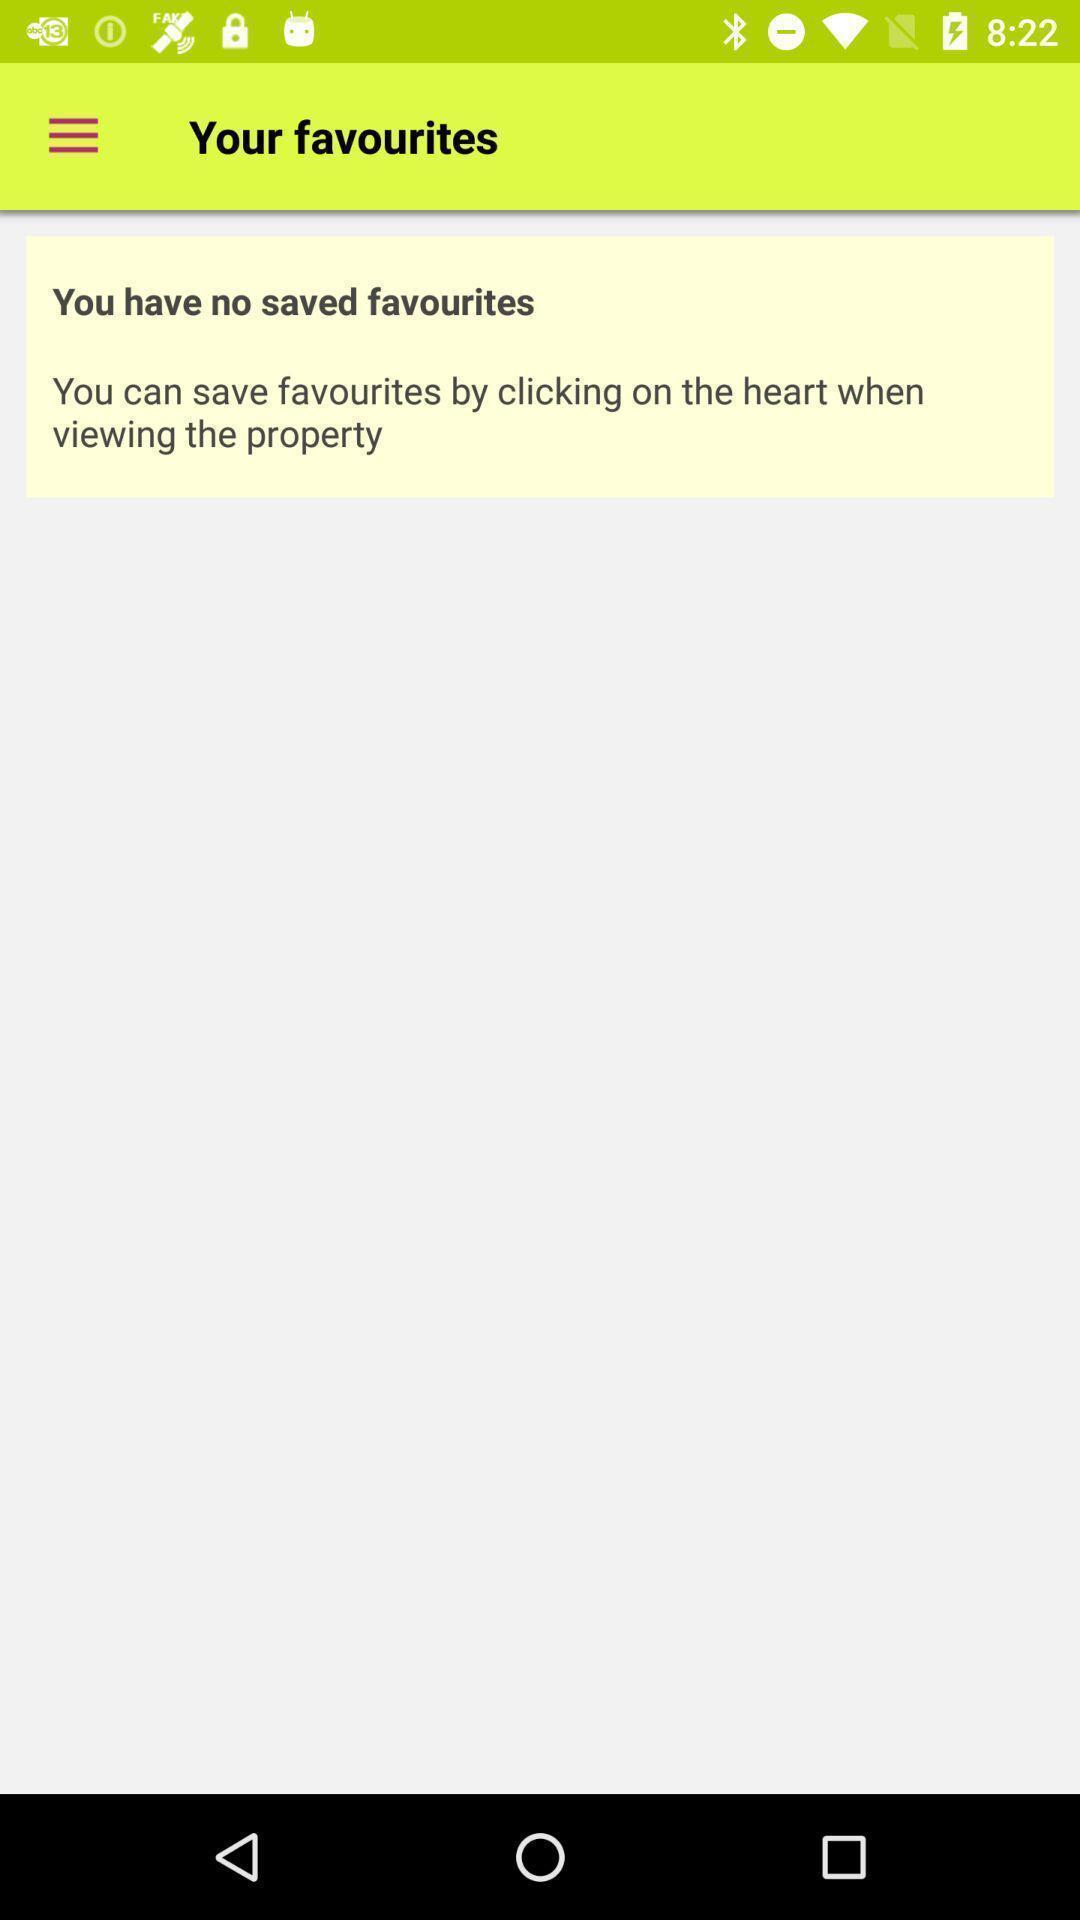What is the overall content of this screenshot? Screen displaying results of saved messages. 